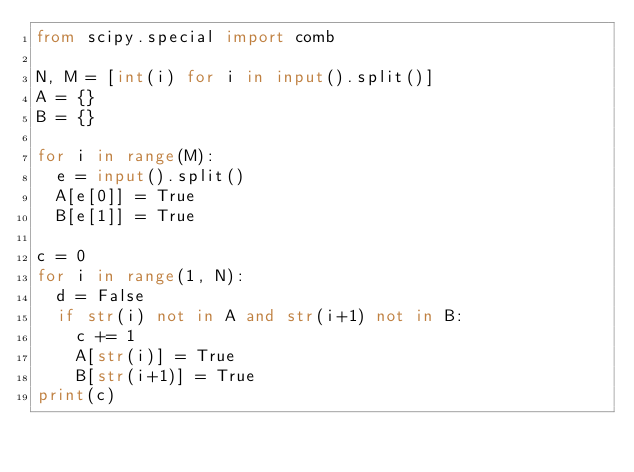Convert code to text. <code><loc_0><loc_0><loc_500><loc_500><_Python_>from scipy.special import comb

N, M = [int(i) for i in input().split()]
A = {}
B = {}

for i in range(M):
  e = input().split()
  A[e[0]] = True
  B[e[1]] = True

c = 0
for i in range(1, N):
  d = False
  if str(i) not in A and str(i+1) not in B:
    c += 1
    A[str(i)] = True
    B[str(i+1)] = True
print(c)</code> 